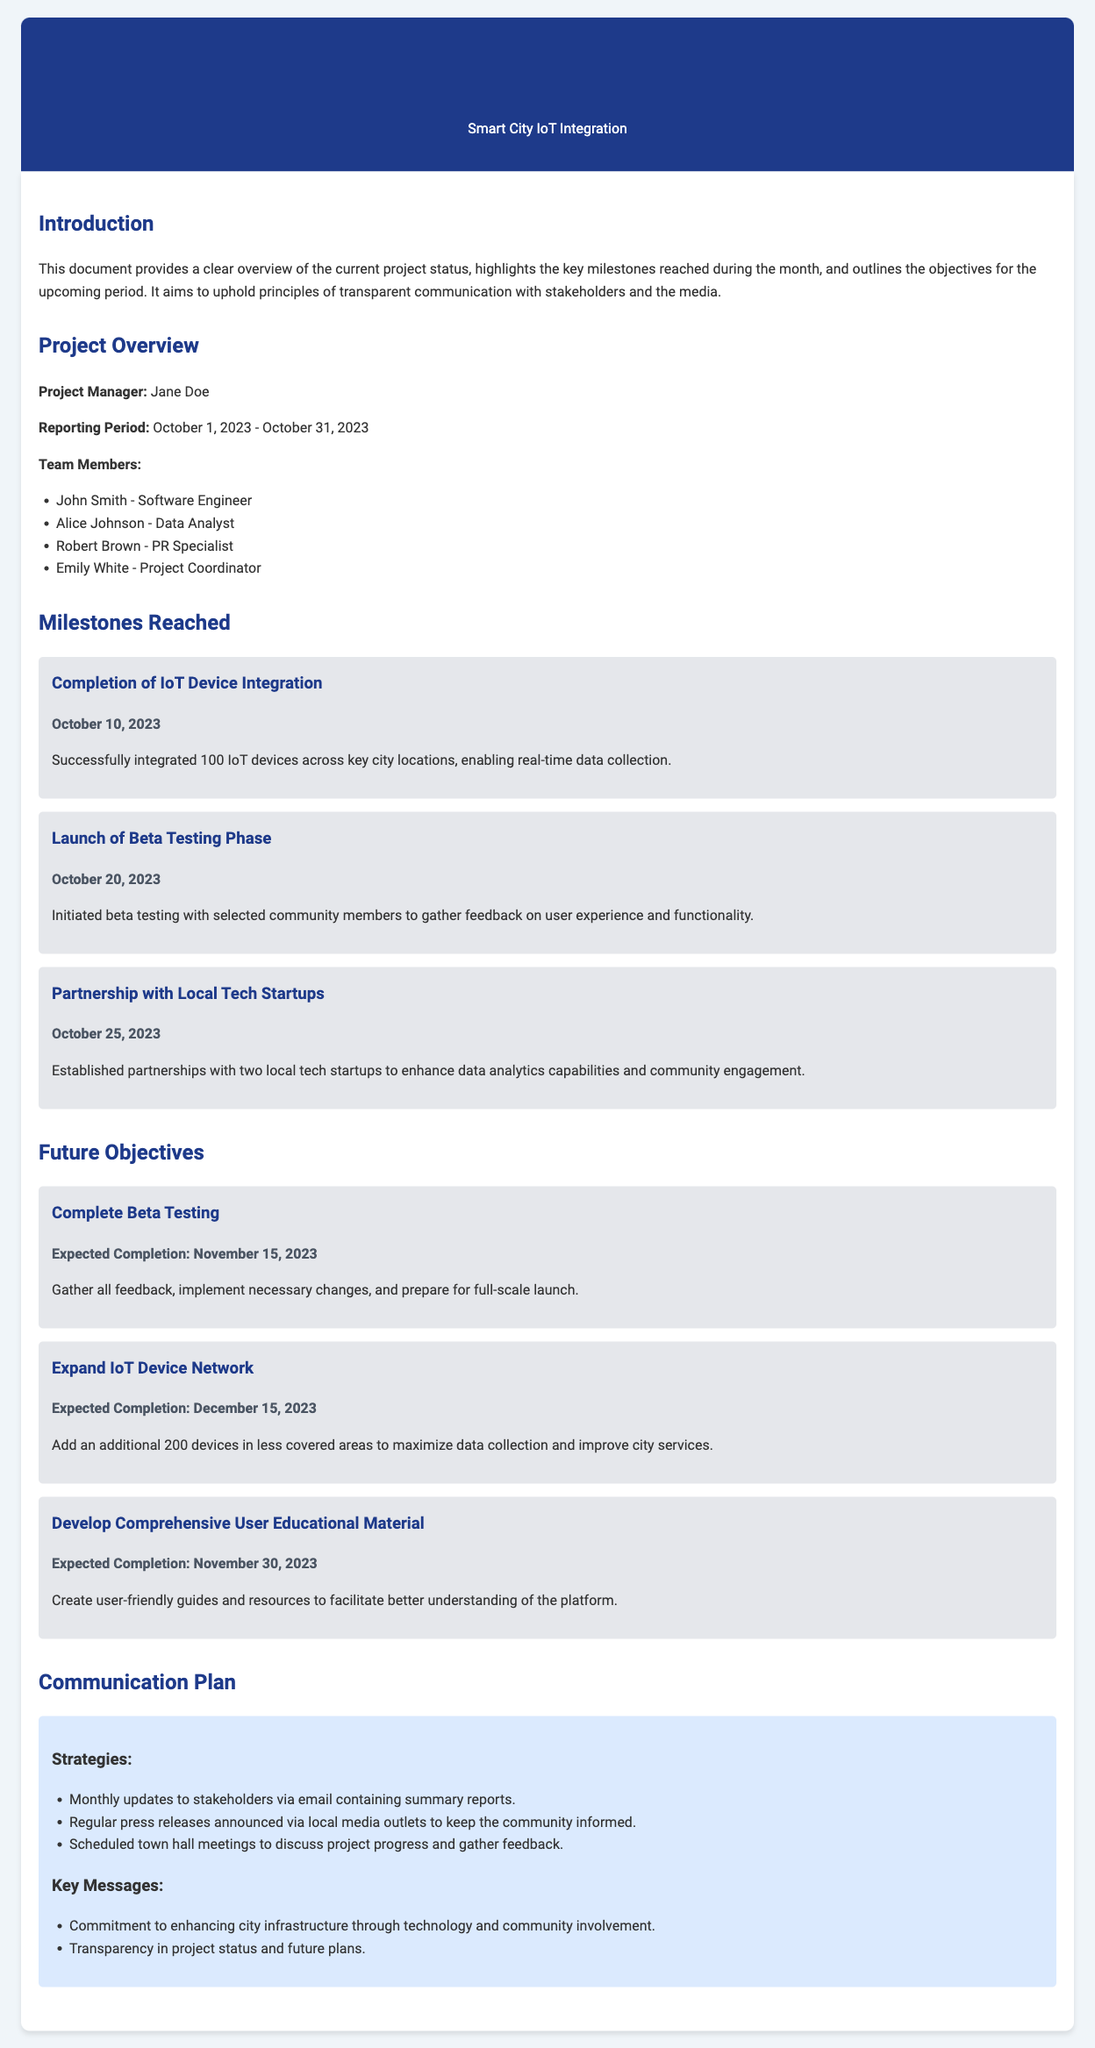What is the project title? The project title is mentioned in the header section of the report.
Answer: Smart City IoT Integration Who is the project manager? The document specifies the project manager under the project overview section.
Answer: Jane Doe When did the beta testing phase start? The date of the beta testing phase launch is provided in the milestones reached section.
Answer: October 20, 2023 How many IoT devices were integrated? The document states the number of devices successfully integrated in the milestones section.
Answer: 100 What is the expected completion date for the user educational material? The document outlines the expected completion date for the objective within the future objectives section.
Answer: November 30, 2023 Which two local tech startups were mentioned as partners? The document mentions that partnerships were established, but the names of the startups are not specified.
Answer: N/A What are the three strategies in the communication plan? The communication plan section lists the strategies used for communication.
Answer: Monthly updates, press releases, town hall meetings What is the aim of the project? The project's aim is described in the introduction section of the report.
Answer: Transparent communication with stakeholders and the media What are the two future objectives? The future objectives section outlines multiple objectives, but two specific ones can be highlighted.
Answer: Complete beta testing and expand IoT device network 